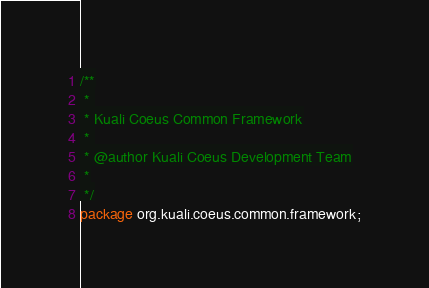<code> <loc_0><loc_0><loc_500><loc_500><_Java_>/**
 * 
 * Kuali Coeus Common Framework
 * 
 * @author Kuali Coeus Development Team
 *
 */
package org.kuali.coeus.common.framework;</code> 